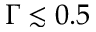<formula> <loc_0><loc_0><loc_500><loc_500>\Gamma \lesssim 0 . 5</formula> 